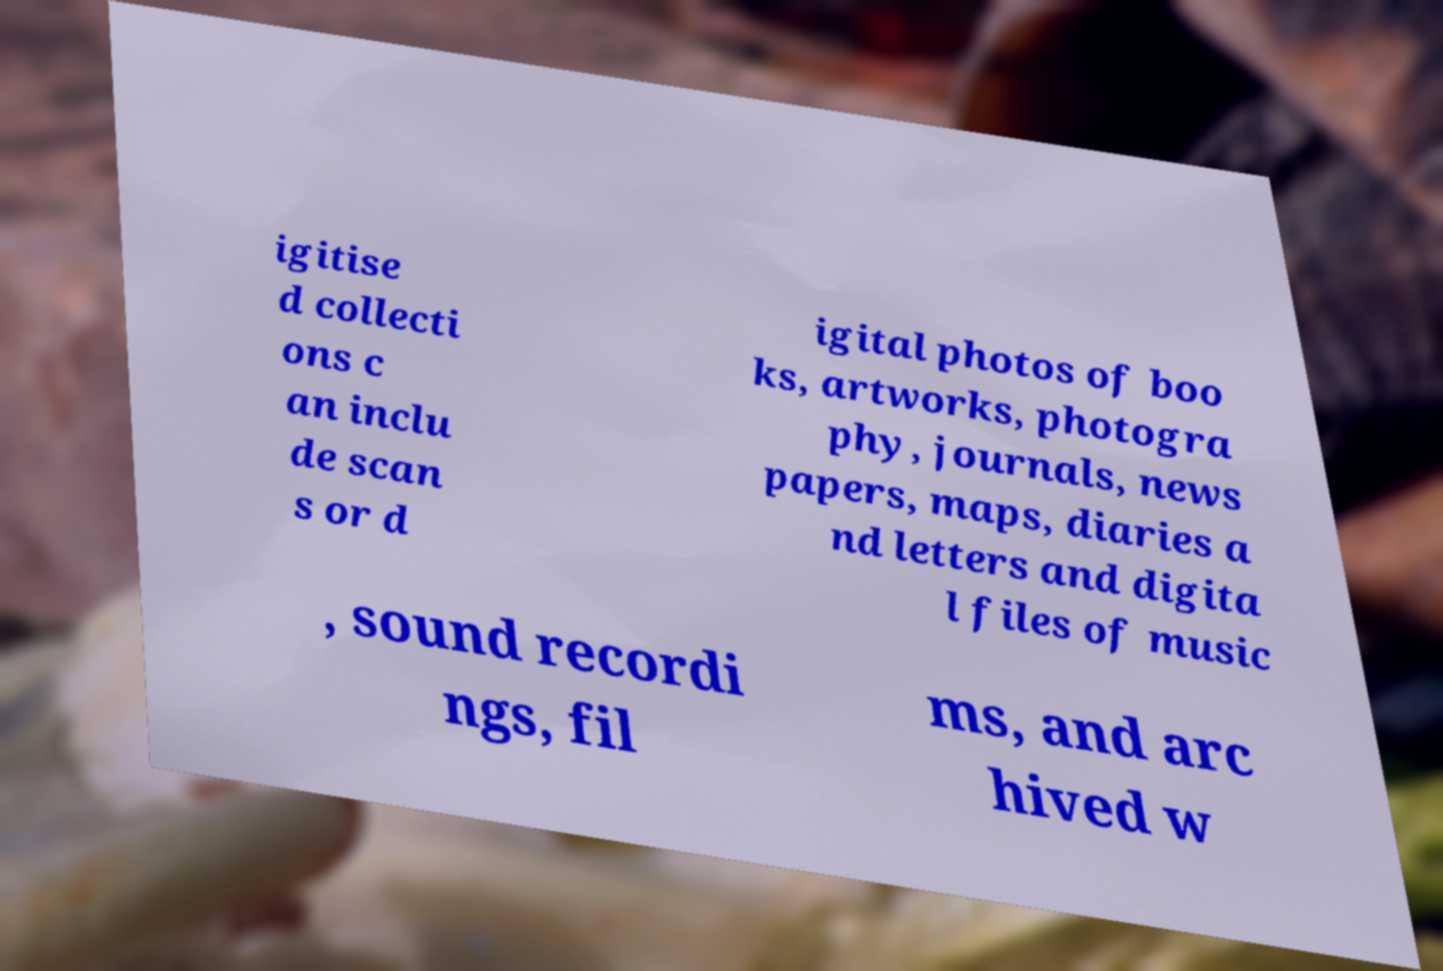Can you accurately transcribe the text from the provided image for me? igitise d collecti ons c an inclu de scan s or d igital photos of boo ks, artworks, photogra phy, journals, news papers, maps, diaries a nd letters and digita l files of music , sound recordi ngs, fil ms, and arc hived w 